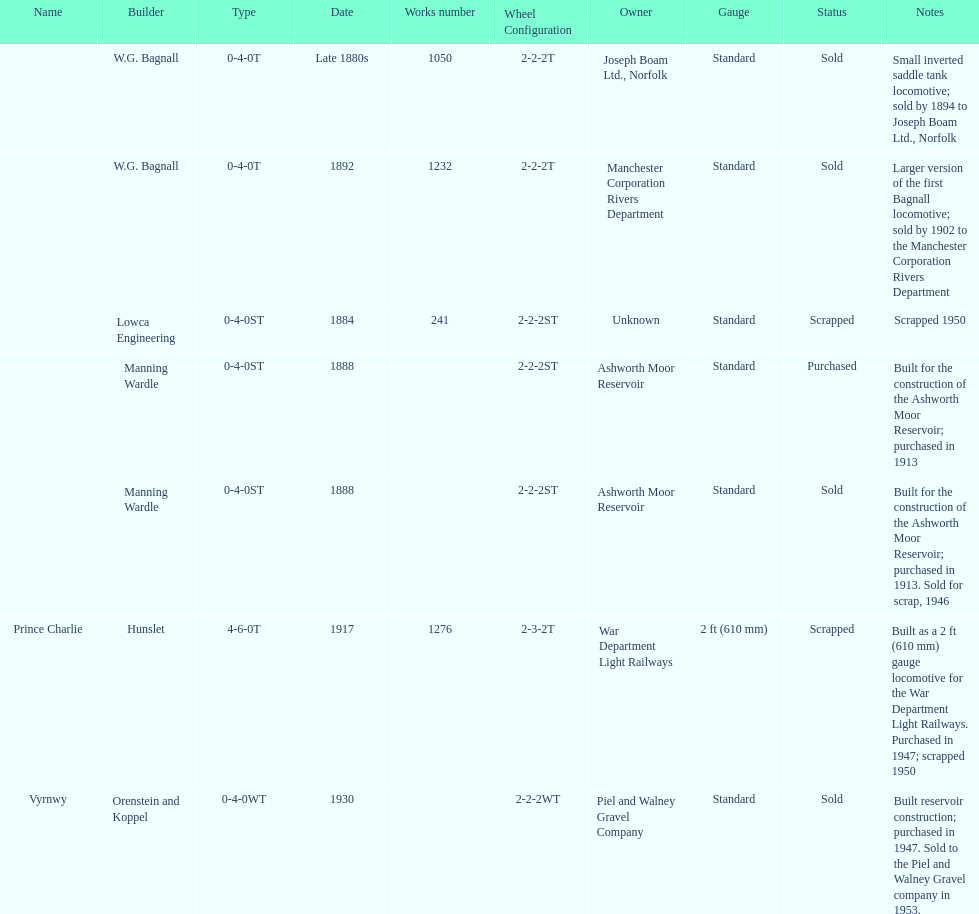List each of the builder's that had a locomotive scrapped. Lowca Engineering, Manning Wardle, Hunslet. 